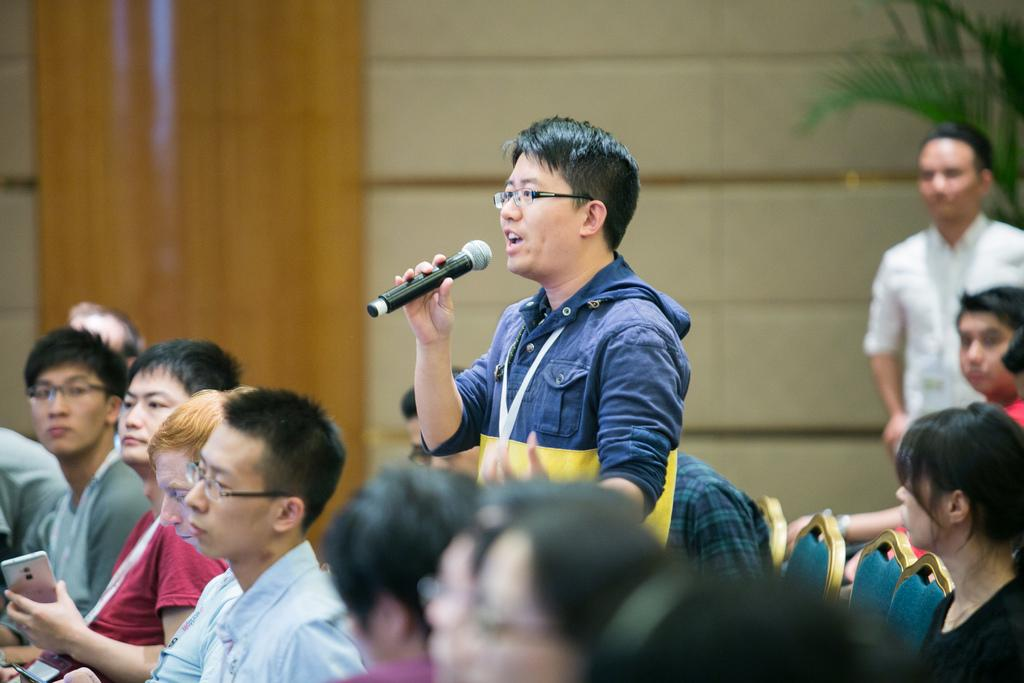What is the person in the image doing? The person is standing in the image and holding a mic in his hands. What are the other people in the image doing? The other people are sitting on chairs in the image. What can be seen in the background of the image? There is a wall and a plant in the background of the image. What is the weight of the snails on the door in the image? There is no door or snails present in the image. 